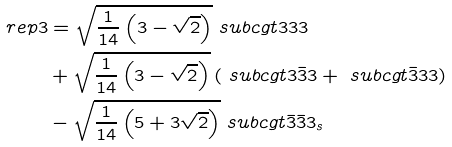Convert formula to latex. <formula><loc_0><loc_0><loc_500><loc_500>\ r e p { 3 } & = \sqrt { \frac { 1 } { 1 4 } \left ( 3 - \sqrt { 2 } \right ) } \ s u b c g t { 3 } { 3 } { 3 } \\ & + \sqrt { \frac { 1 } { 1 4 } \left ( 3 - \sqrt { 2 } \right ) } \left ( \ s u b c g t { 3 } { \bar { 3 } } { 3 } + \ s u b c g t { \bar { 3 } } { 3 } { 3 } \right ) \\ & - \sqrt { \frac { 1 } { 1 4 } \left ( 5 + 3 \sqrt { 2 } \right ) } \ s u b c g t { \bar { 3 } } { \bar { 3 } } { 3 _ { s } }</formula> 